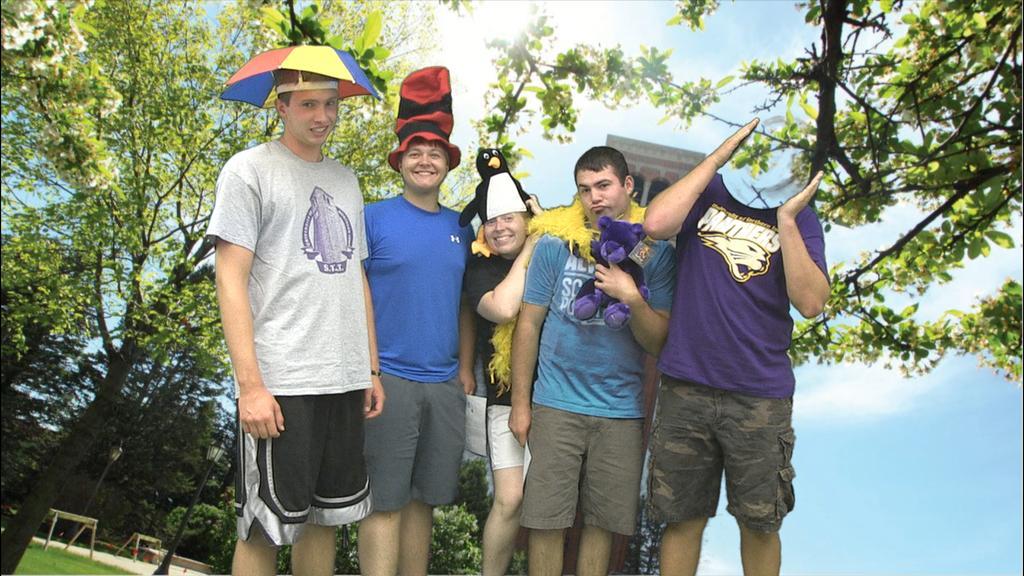How would you summarize this image in a sentence or two? This is an edited picture, I can see few people standing and couple of them wore caps on their heads and a man wore small umbrella to his head and another man holding a soft toy and I can see trees and a blue cloudy Sky and a pole light. 